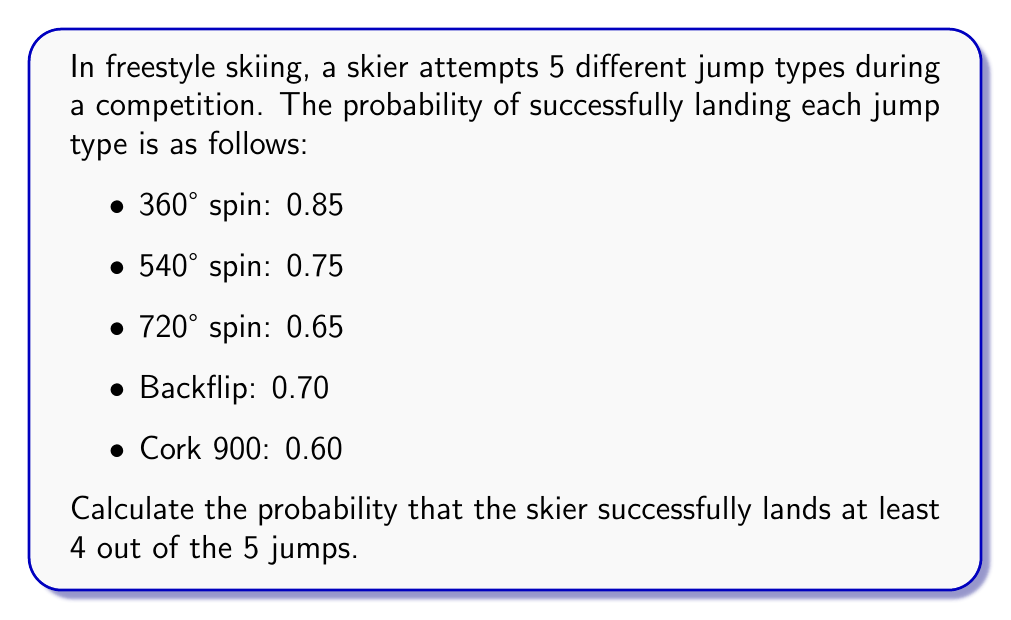Could you help me with this problem? To solve this problem, we can use the concept of binomial probability. We need to calculate the probability of landing exactly 4 jumps plus the probability of landing all 5 jumps.

Let's break it down step-by-step:

1) First, we need to calculate the overall probability of a successful landing for any jump:
   $p = \frac{0.85 + 0.75 + 0.65 + 0.70 + 0.60}{5} = 0.71$

2) The probability of an unsuccessful landing is:
   $q = 1 - p = 1 - 0.71 = 0.29$

3) Now, we can use the binomial probability formula:
   $P(X = k) = \binom{n}{k} p^k q^{n-k}$
   
   Where:
   $n$ is the total number of trials (5 in this case)
   $k$ is the number of successes
   $p$ is the probability of success on each trial
   $q$ is the probability of failure on each trial

4) We need to calculate $P(X = 4)$ and $P(X = 5)$:

   $P(X = 4) = \binom{5}{4} (0.71)^4 (0.29)^1$
   $= 5 \cdot 0.71^4 \cdot 0.29$
   $= 5 \cdot 0.2541 \cdot 0.29$
   $= 0.3683$

   $P(X = 5) = \binom{5}{5} (0.71)^5 (0.29)^0$
   $= 1 \cdot 0.71^5$
   $= 0.1805$

5) The total probability of landing at least 4 jumps is the sum of these probabilities:
   $P(X \geq 4) = P(X = 4) + P(X = 5) = 0.3683 + 0.1805 = 0.5488$

Therefore, the probability of landing at least 4 out of 5 jumps is approximately 0.5488 or 54.88%.
Answer: $0.5488$ or $54.88\%$ 